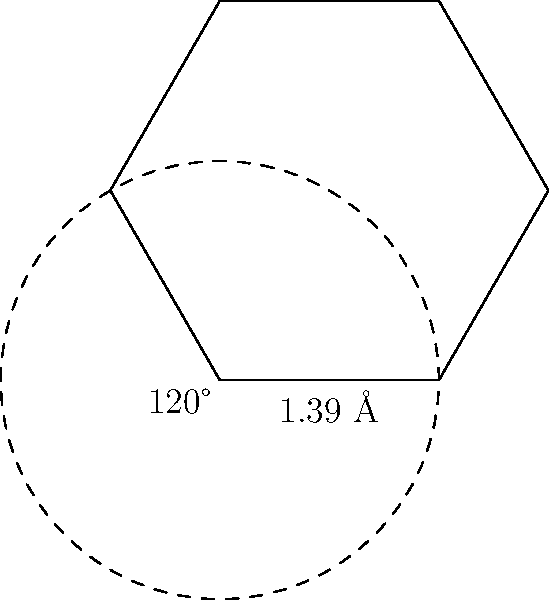Calculate the area of a benzene ring molecule given that the carbon-carbon bond length is 1.39 Å and the bond angle is 120°. Express your answer in square Ångströms (Å²) rounded to two decimal places. To calculate the area of the benzene ring, we can follow these steps:

1) The benzene ring is a regular hexagon. We can divide it into six equilateral triangles.

2) The area of the hexagon will be 6 times the area of one equilateral triangle.

3) For an equilateral triangle:
   Area = $\frac{\sqrt{3}}{4}a^2$, where $a$ is the side length (bond length in this case).

4) The bond length is 1.39 Å, so:
   Area of one triangle = $\frac{\sqrt{3}}{4}(1.39)^2 = 0.8371$ Å²

5) The total area of the benzene ring:
   Total Area = $6 \times 0.8371 = 5.0226$ Å²

6) Rounding to two decimal places: 5.02 Å²

This method avoids the need for trigonometric calculations and provides an accurate result based on the given bond length.
Answer: 5.02 Å² 